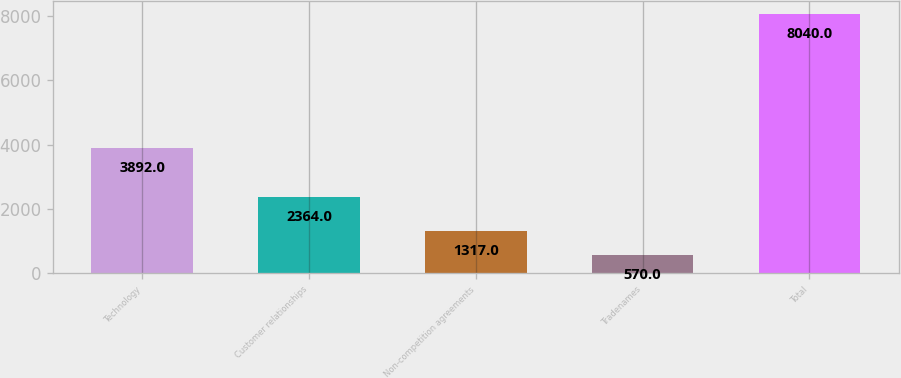Convert chart. <chart><loc_0><loc_0><loc_500><loc_500><bar_chart><fcel>Technology<fcel>Customer relationships<fcel>Non-competition agreements<fcel>Tradenames<fcel>Total<nl><fcel>3892<fcel>2364<fcel>1317<fcel>570<fcel>8040<nl></chart> 